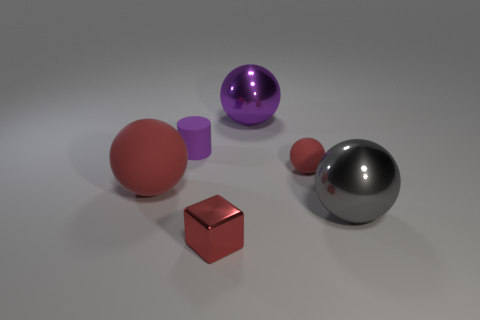Add 1 big metallic spheres. How many objects exist? 7 Subtract all cubes. How many objects are left? 5 Add 2 small rubber blocks. How many small rubber blocks exist? 2 Subtract 0 green cylinders. How many objects are left? 6 Subtract all purple objects. Subtract all large cyan metal spheres. How many objects are left? 4 Add 2 small red rubber things. How many small red rubber things are left? 3 